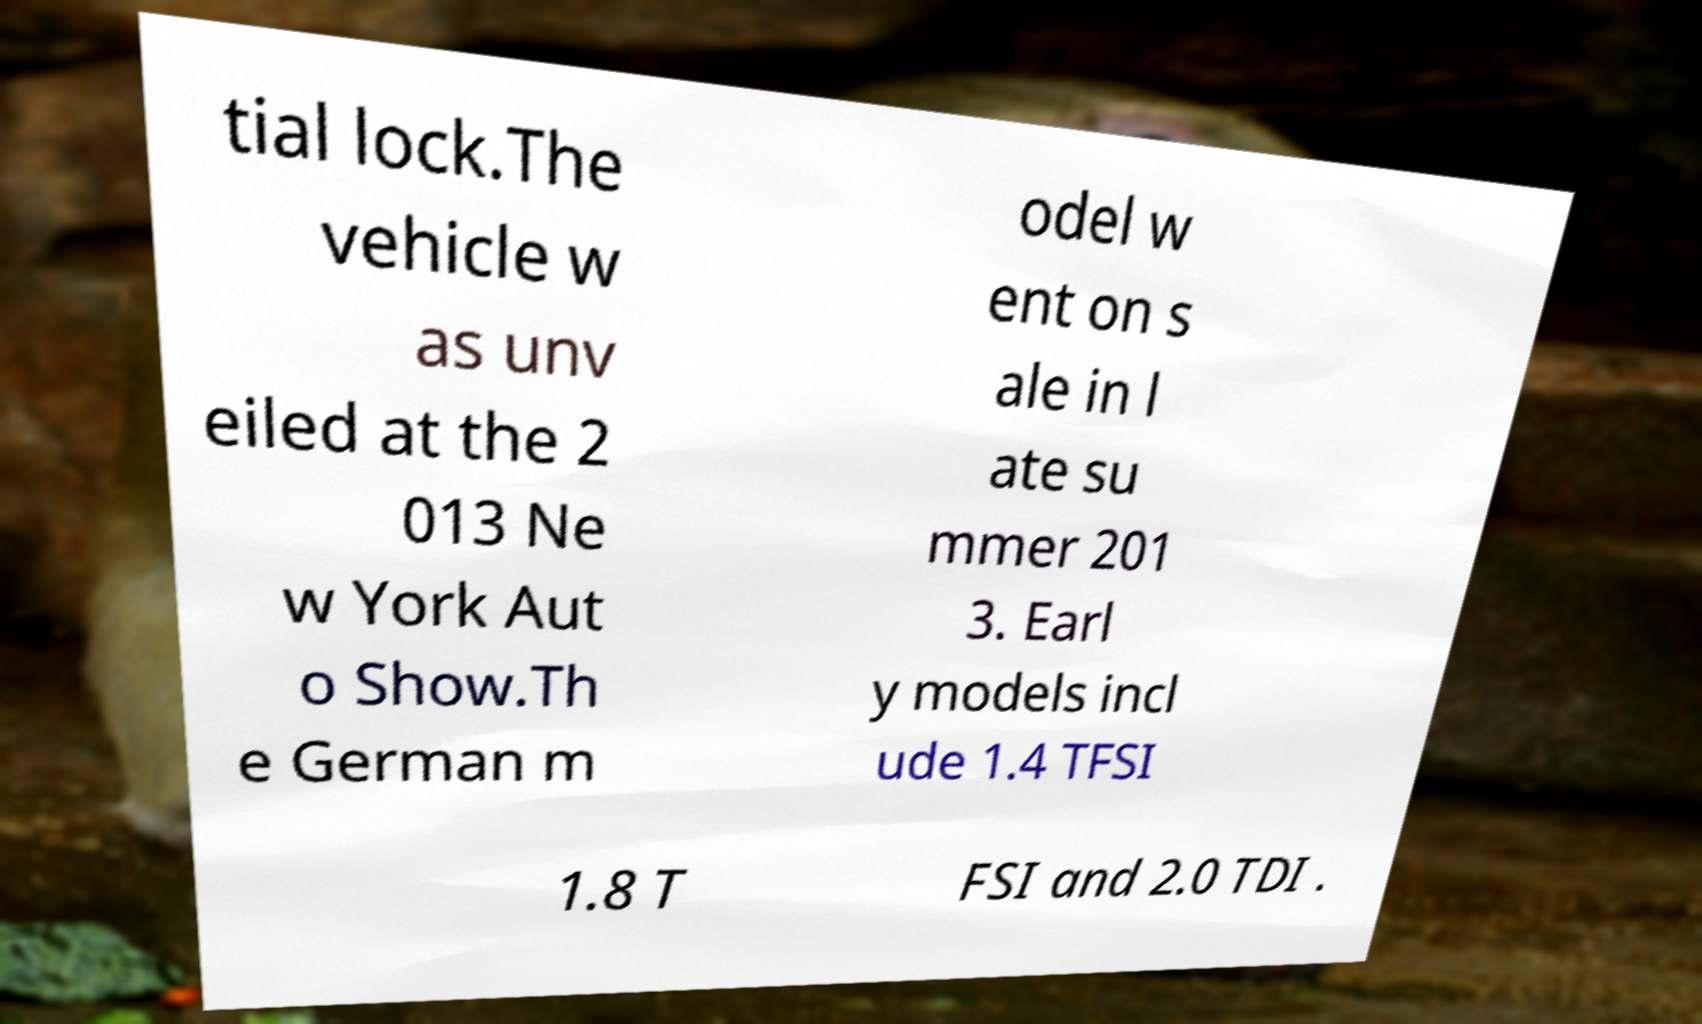What messages or text are displayed in this image? I need them in a readable, typed format. tial lock.The vehicle w as unv eiled at the 2 013 Ne w York Aut o Show.Th e German m odel w ent on s ale in l ate su mmer 201 3. Earl y models incl ude 1.4 TFSI 1.8 T FSI and 2.0 TDI . 